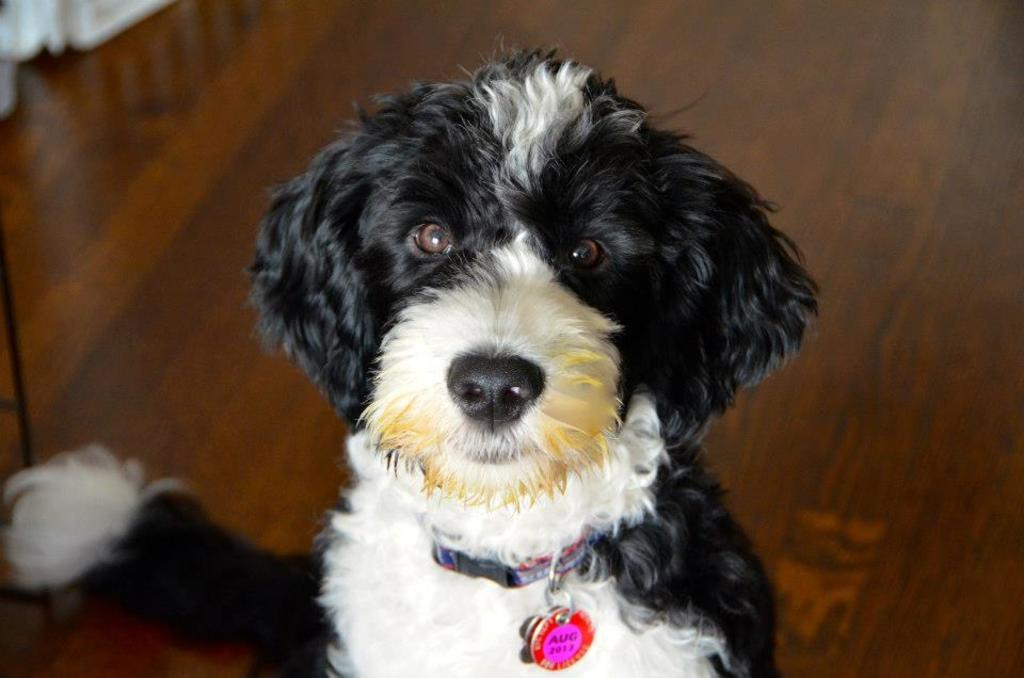What type of animal is in the image? There is a dog in the image. Where is the dog located in the image? The dog is on the floor. What else can be seen on the floor in the image? There are objects on the floor on the left side of the image. How many kittens are playing with the dog's neck in the image? There are no kittens present in the image, and the dog's neck is not being played with. 